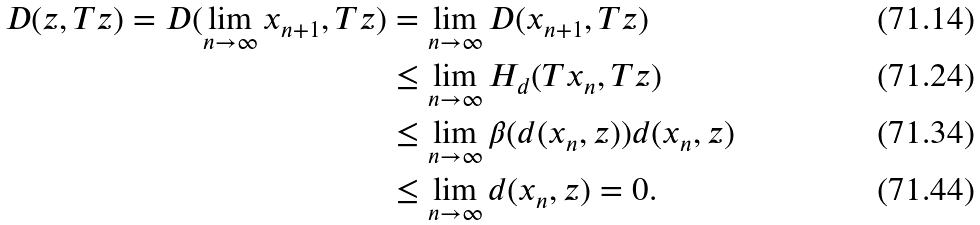<formula> <loc_0><loc_0><loc_500><loc_500>D ( z , T z ) = D ( \lim _ { n \to \infty } x _ { n + 1 } , T z ) & = \lim _ { n \to \infty } D ( x _ { n + 1 } , T z ) \\ & \leq \lim _ { n \to \infty } H _ { d } ( T x _ { n } , T z ) \\ & \leq \lim _ { n \to \infty } \beta ( d ( x _ { n } , z ) ) d ( x _ { n } , z ) \\ & \leq \lim _ { n \to \infty } d ( x _ { n } , z ) = 0 .</formula> 